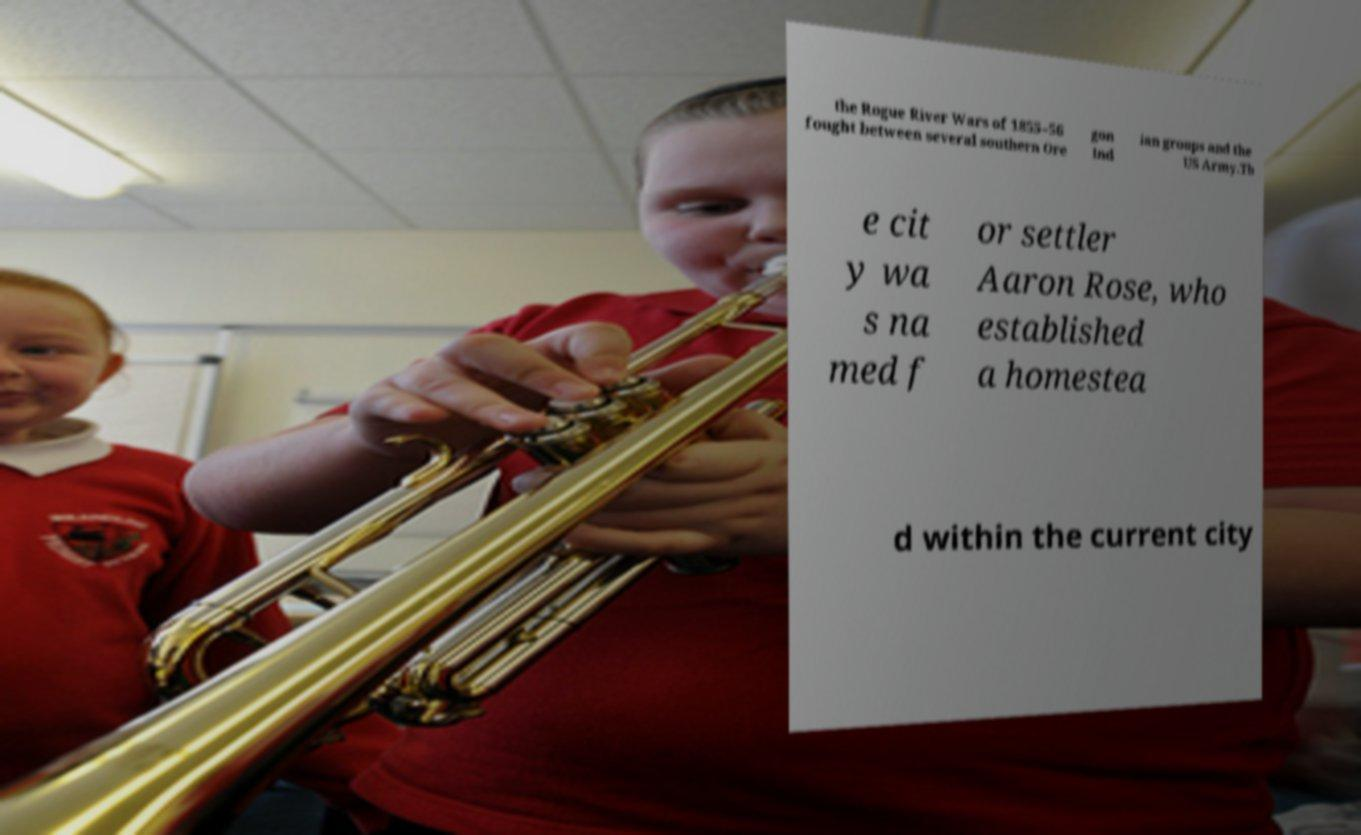For documentation purposes, I need the text within this image transcribed. Could you provide that? the Rogue River Wars of 1855–56 fought between several southern Ore gon Ind ian groups and the US Army.Th e cit y wa s na med f or settler Aaron Rose, who established a homestea d within the current city 